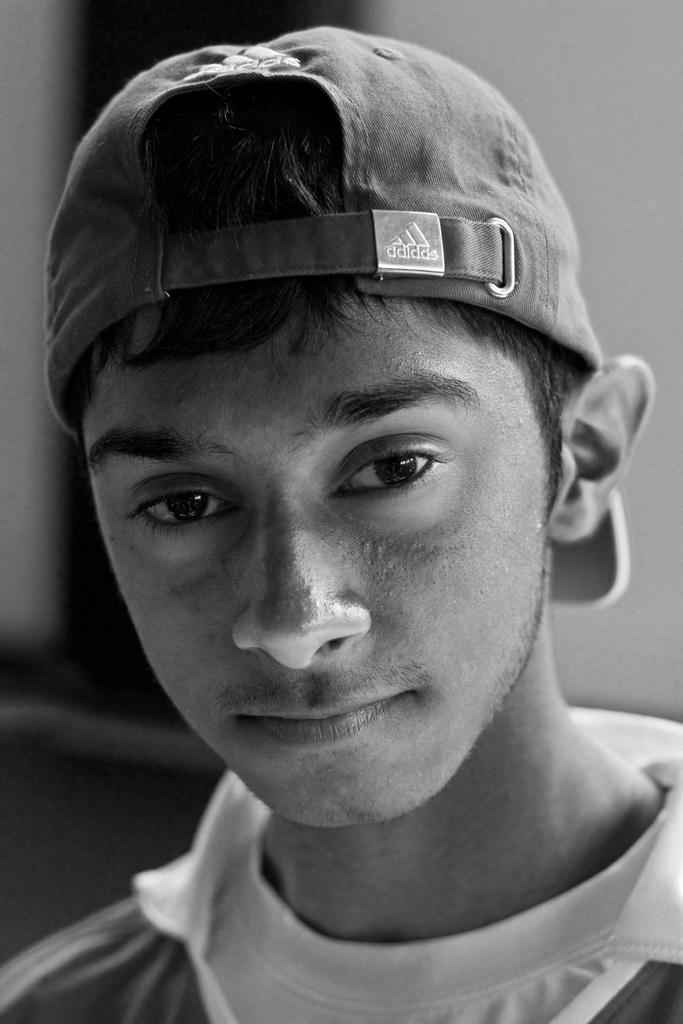What is the color scheme of the image? The image is black and white. Who or what is the main subject in the image? There is a person in the middle of the image. What is the person wearing on their head? The person is wearing a cap. What type of arch can be seen in the background of the image? There is no arch present in the image; it is a black and white image featuring a person wearing a cap. 